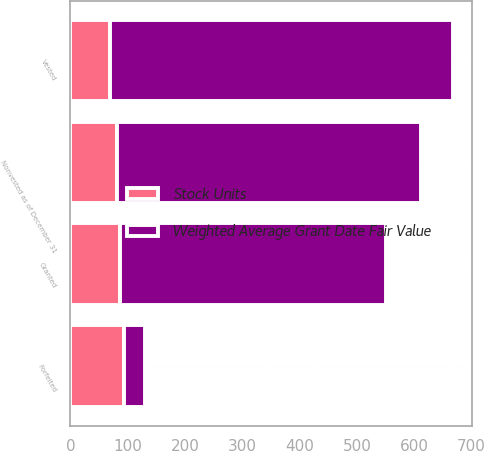Convert chart. <chart><loc_0><loc_0><loc_500><loc_500><stacked_bar_chart><ecel><fcel>Nonvested as of December 31<fcel>Granted<fcel>Vested<fcel>Forfeited<nl><fcel>Weighted Average Grant Date Fair Value<fcel>530<fcel>463<fcel>599<fcel>36<nl><fcel>Stock Units<fcel>81.94<fcel>86.84<fcel>68.75<fcel>94.3<nl></chart> 